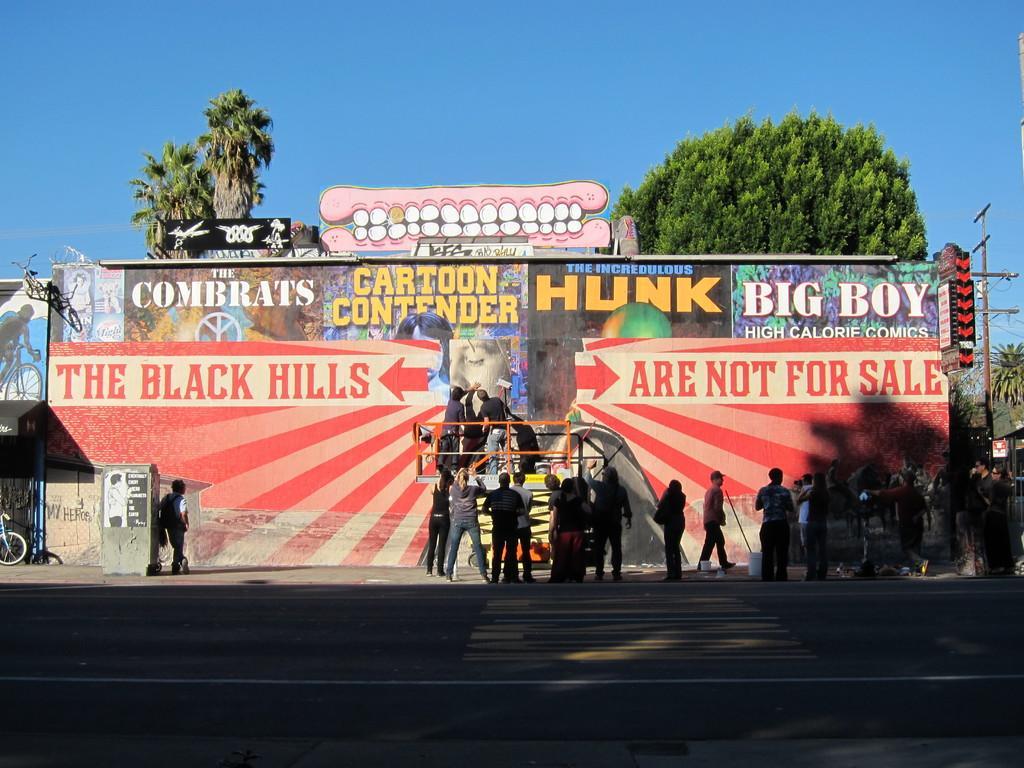Please provide a concise description of this image. In this picture we can see many people standing before a wall with graffiti. Behind it, we have trees. 